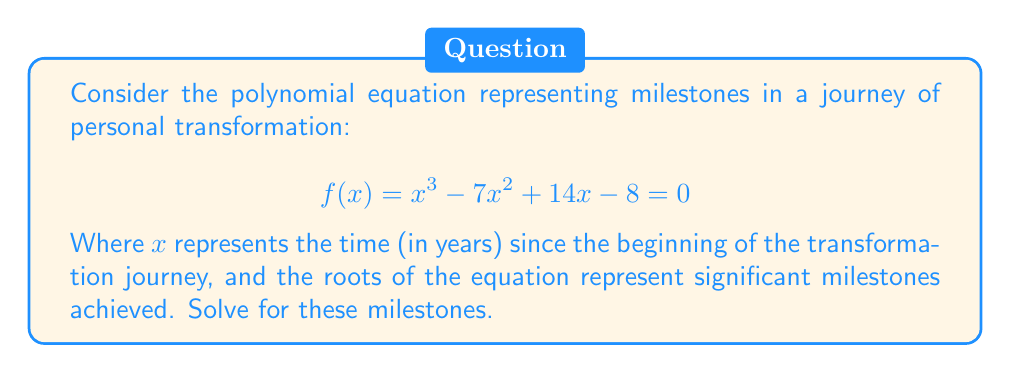Solve this math problem. To solve this polynomial equation, we'll use the rational root theorem and synthetic division:

1) Potential rational roots: Factors of the constant term (8)
   $\pm 1, \pm 2, \pm 4, \pm 8$

2) Test these potential roots using synthetic division:

   Testing $x = 1$:
   $$ 1 | 1 \quad -7 \quad 14 \quad -8 $$
   $$ \quad\quad 1 \quad -6 \quad 8 $$
   $$ 1 \quad -6 \quad 8 \quad 0 $$

   We found our first root: $x = 1$

3) Divide the original polynomial by $(x - 1)$:
   $f(x) = (x - 1)(x^2 - 6x + 8)$

4) Solve the quadratic equation $x^2 - 6x + 8 = 0$:
   Using the quadratic formula: $x = \frac{-b \pm \sqrt{b^2 - 4ac}}{2a}$
   
   $x = \frac{6 \pm \sqrt{36 - 32}}{2} = \frac{6 \pm 2}{2}$

   $x = 4$ or $x = 2$

5) Therefore, the roots of the equation are $x = 1$, $x = 2$, and $x = 4$.

These roots represent significant milestones achieved at 1 year, 2 years, and 4 years into the journey of personal transformation.
Answer: $x = 1, 2, 4$ 